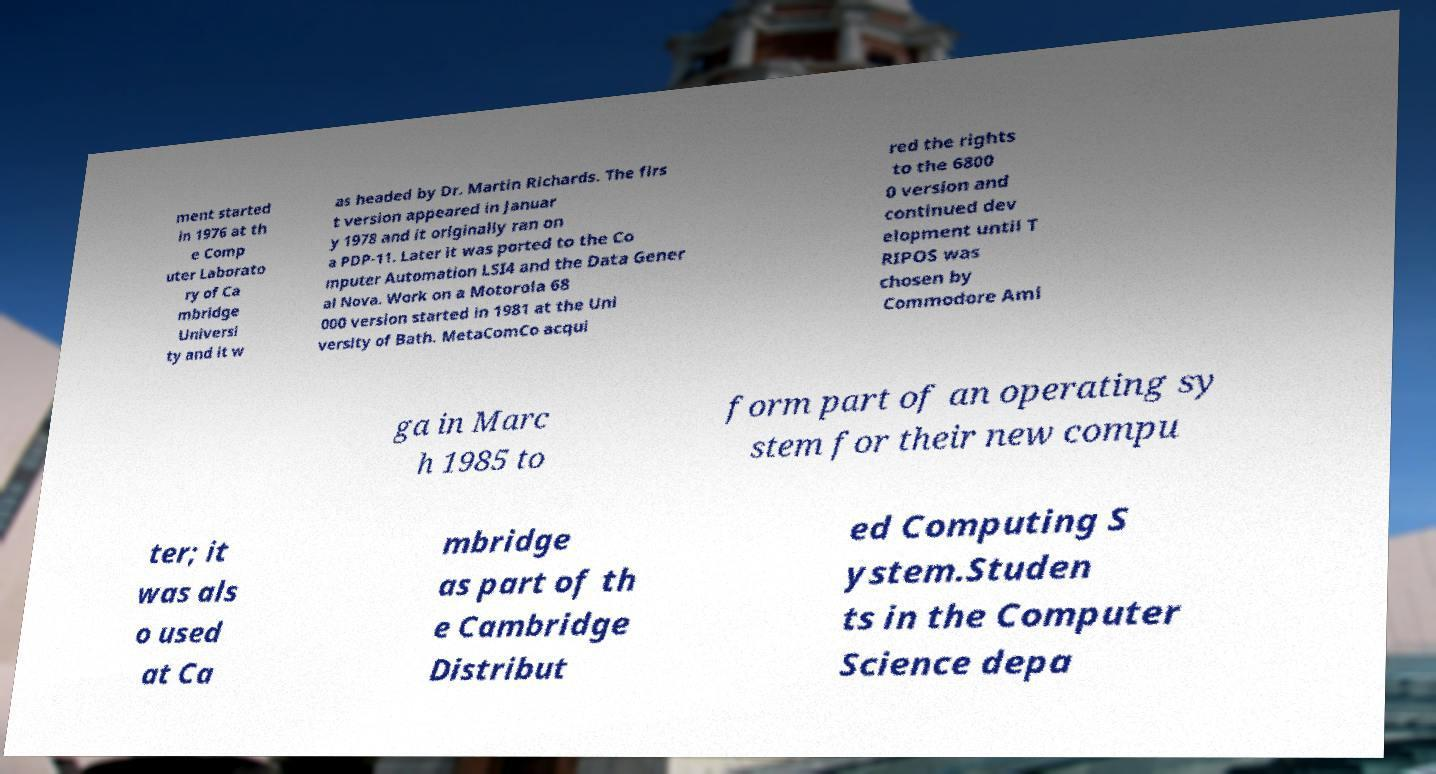Can you accurately transcribe the text from the provided image for me? ment started in 1976 at th e Comp uter Laborato ry of Ca mbridge Universi ty and it w as headed by Dr. Martin Richards. The firs t version appeared in Januar y 1978 and it originally ran on a PDP-11. Later it was ported to the Co mputer Automation LSI4 and the Data Gener al Nova. Work on a Motorola 68 000 version started in 1981 at the Uni versity of Bath. MetaComCo acqui red the rights to the 6800 0 version and continued dev elopment until T RIPOS was chosen by Commodore Ami ga in Marc h 1985 to form part of an operating sy stem for their new compu ter; it was als o used at Ca mbridge as part of th e Cambridge Distribut ed Computing S ystem.Studen ts in the Computer Science depa 